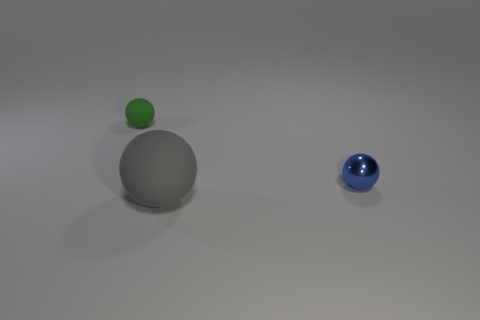Is there any other thing that has the same material as the tiny blue object?
Ensure brevity in your answer.  No. Are there more large gray rubber spheres than rubber balls?
Provide a short and direct response. No. Is there a big red thing that has the same material as the gray sphere?
Offer a very short reply. No. What shape is the object that is both right of the small rubber ball and to the left of the small blue metallic sphere?
Your answer should be compact. Sphere. How many other objects are the same shape as the green thing?
Provide a succinct answer. 2. The shiny sphere is what size?
Your answer should be very brief. Small. What number of objects are tiny rubber balls or small purple cylinders?
Ensure brevity in your answer.  1. What size is the thing left of the large rubber thing?
Make the answer very short. Small. Is there anything else that is the same size as the green rubber sphere?
Provide a succinct answer. Yes. What color is the ball that is both behind the large matte thing and on the left side of the tiny blue thing?
Keep it short and to the point. Green. 